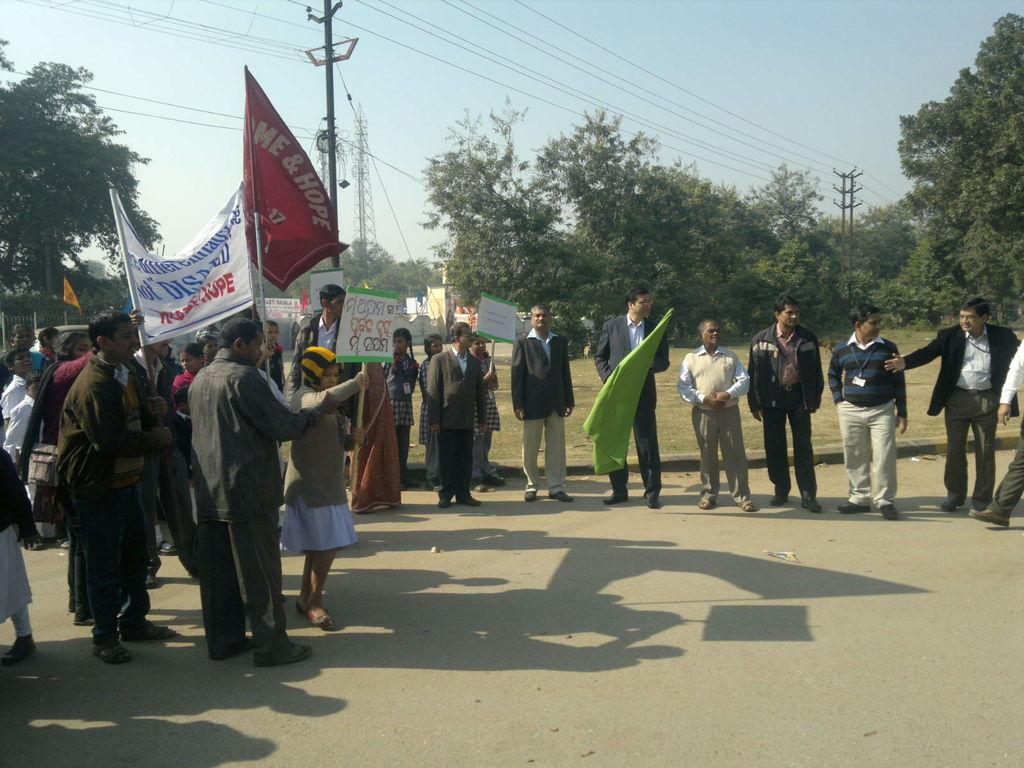Who is present in the image? There are people in the image. What are the people doing in the image? The people are standing and doing a protest. What can be seen in the background of the image? There are trees behind the people. What other object is present in the image? There is an electric pole present in the image. What type of voice can be heard from the people in the image? There is no audio in the image, so it is not possible to determine the type of voice or any sounds made by the people. 